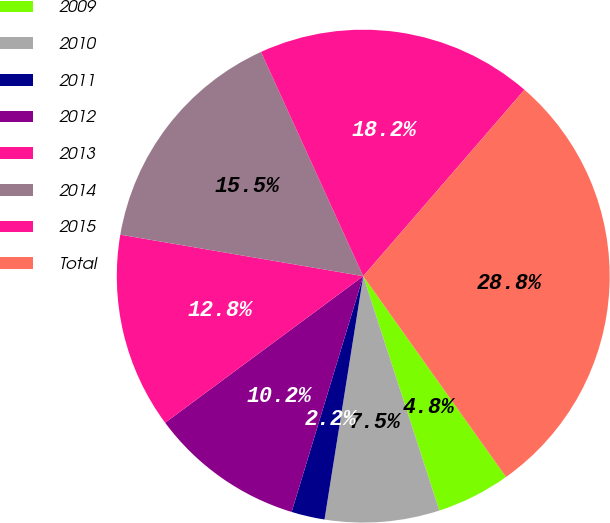<chart> <loc_0><loc_0><loc_500><loc_500><pie_chart><fcel>2009<fcel>2010<fcel>2011<fcel>2012<fcel>2013<fcel>2014<fcel>2015<fcel>Total<nl><fcel>4.84%<fcel>7.51%<fcel>2.18%<fcel>10.17%<fcel>12.83%<fcel>15.5%<fcel>18.16%<fcel>28.81%<nl></chart> 